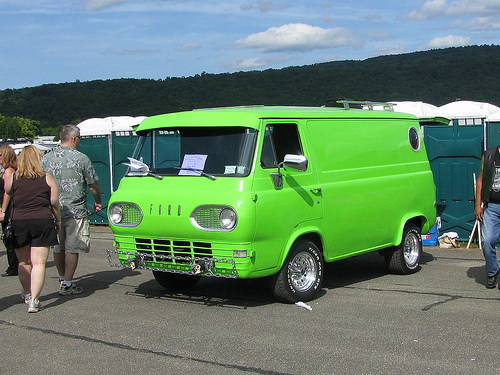<image>
Is the paper in the car? No. The paper is not contained within the car. These objects have a different spatial relationship. 